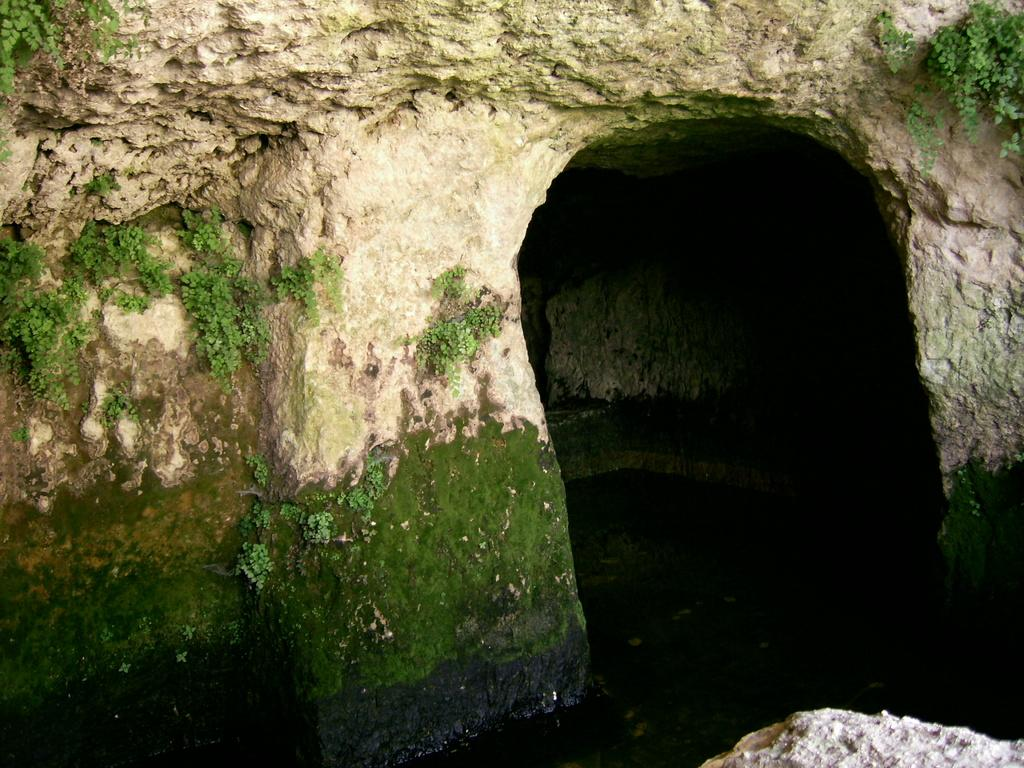What is the main structure in the foreground of the image? There is an arch in the foreground of the image. What material is the arch made of? The arch is made of rock. What can be seen at the bottom of the image? There is water and a rock at the bottom of the image. What is growing on the rock? There are plants on the rock. How many chairs are placed on the rock in the image? There are no chairs present in the image. What is placed in the middle of the arch in the image? There is no object placed in the middle of the arch in the image. 